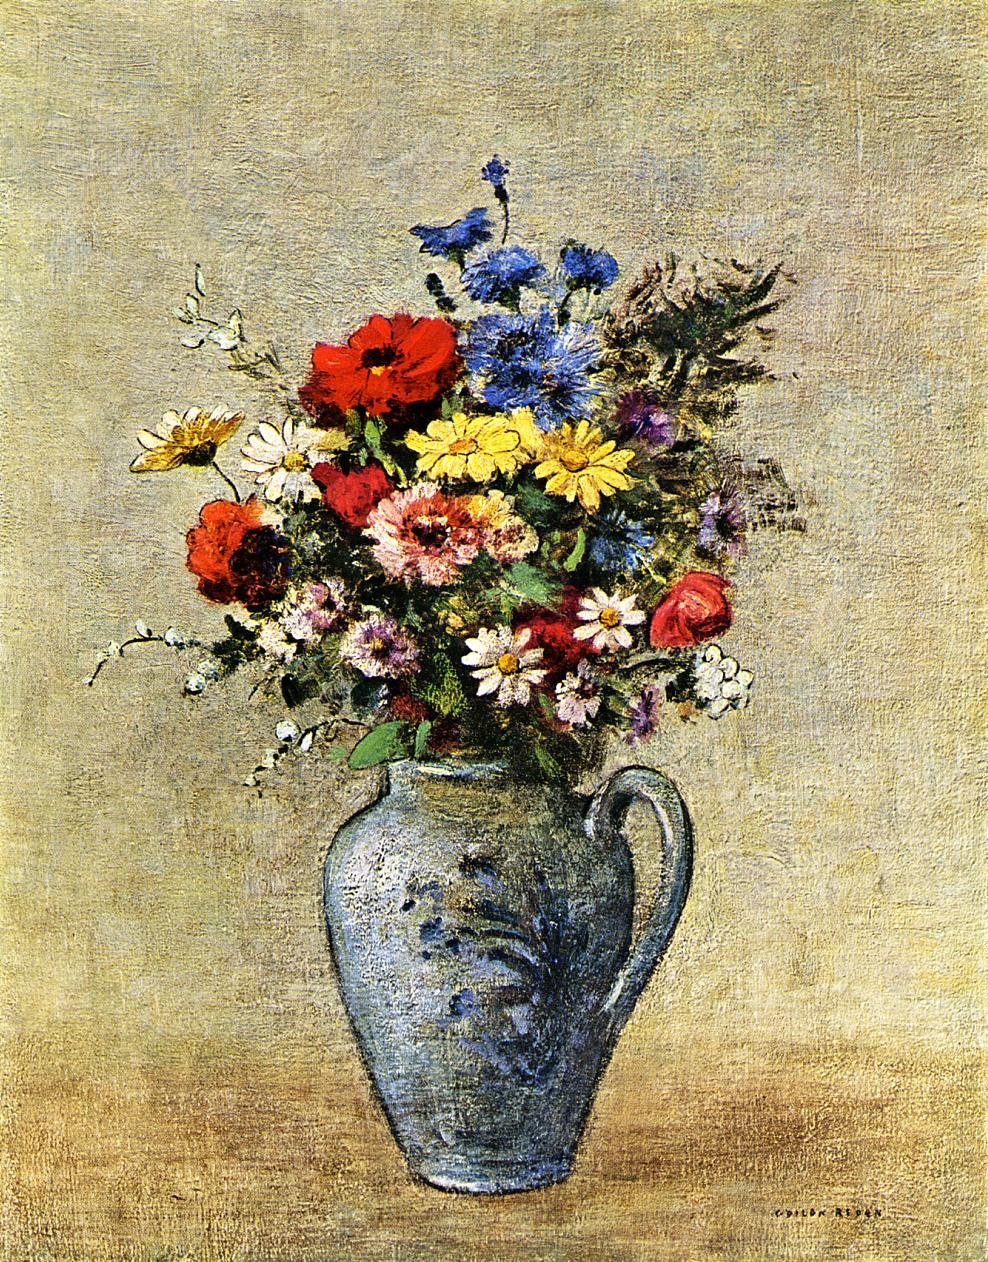What emotions do you think the artist intended to evoke with this bouquet of flowers? The artist likely aimed to evoke feelings of joy and vitality, conveyed through the use of bright, lively colors and a relaxed, spontaneous brushwork. The placement and choice of flowers can also suggest a deeper sentiment of nostalgia or memory, as often seen in traditional still life compositions that evoke personal or seasonal themes. 